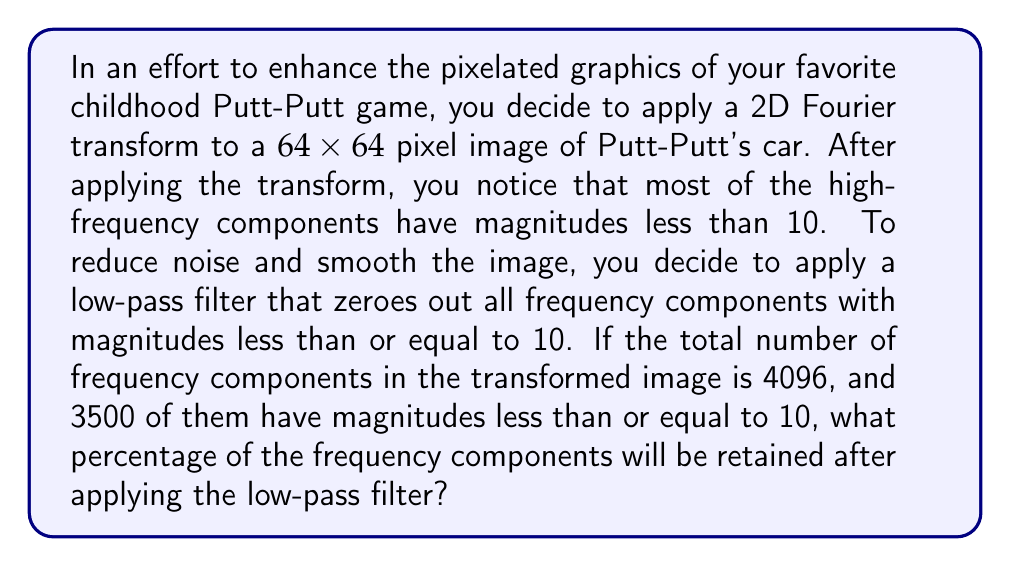Provide a solution to this math problem. Let's approach this step-by-step:

1) First, let's understand what we're given:
   - The image is $64 \times 64$ pixels
   - The 2D Fourier transform has been applied
   - There are 4096 total frequency components
   - 3500 components have magnitudes ≤ 10
   - We're applying a low-pass filter that removes components with magnitudes ≤ 10

2) The total number of frequency components in a 2D Fourier transform of an $N \times N$ image is $N^2$. This checks out with our given information:

   $64 \times 64 = 4096$

3) The number of components that will be retained are those with magnitudes > 10. We can calculate this:

   Components retained = Total components - Components removed
   $= 4096 - 3500 = 596$

4) To calculate the percentage, we use the formula:

   Percentage = $\frac{\text{Part}}{\text{Whole}} \times 100\%$

   $= \frac{596}{4096} \times 100\%$

5) Simplifying:
   $= 0.1455078125 \times 100\%$
   $\approx 14.55\%$

Therefore, approximately 14.55% of the frequency components will be retained after applying the low-pass filter.
Answer: 14.55% 